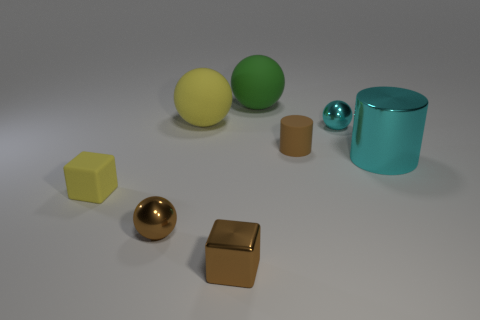Can you tell me the colors of the objects starting from the left? From the left, there is a yellow matte cube, a golden shiny sphere, a bronze shiny cube, a large yellow matte sphere, a green matte sphere, a small blue metallic sphere, and a cyan shiny cylinder. 